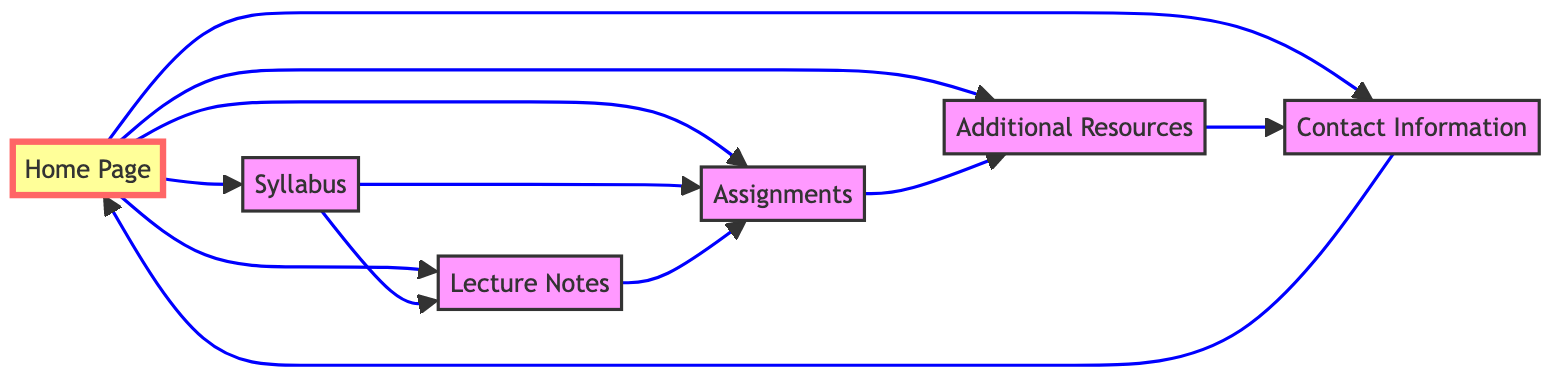What is the total number of HTML pages represented in the diagram? The diagram lists six HTML pages: Home Page, Syllabus, Lecture Notes, Assignments, Additional Resources, and Contact Information. Therefore, by counting each unique page mentioned, we find the total is six.
Answer: 6 Which page is directly linked to the Home Page? The Home Page is connected to five other pages: Syllabus, Lecture Notes, Assignments, Additional Resources, and Contact Information. To determine the direct links, we look at the edges emanating from the Home node, confirming these connections.
Answer: Syllabus, Lecture Notes, Assignments, Additional Resources, Contact Information How many hyperlinks are present in total within the diagram? The diagram contains eleven directed edges representing the hyperlinks between various pages. By counting each pair in the hyperlinks list, we find there are a total of eleven connections.
Answer: 11 From which page can you access the Additional Resources page? The Additional Resources page can be accessed directly from the Assignments page. This connection is found by examining the edges leading to the Additional Resources node and confirming that there is a direct link from Assignments.
Answer: Assignments What is the relationship between the Contact Information and Home Page? The Contact Information page links back to the Home Page. This relationship can be identified by tracing the edge that flows from the Contact node to the Home node in the diagram, indicating a directed connection.
Answer: Links back Which page has the most outgoing hyperlinks? The Home Page has five outgoing hyperlinks, connecting it to the Syllabus, Lecture Notes, Assignments, Additional Resources, and Contact Information pages. By examining the edges connected to each node, we see that the Home Page has more outgoing connections than any other page.
Answer: Home Page If a user is on the Lecture Notes page, which page can they navigate to with only one click? From the Lecture Notes page, a user can immediately navigate to the Assignments page. This is determined by checking the edges that originate from the Lecture Notes node, revealing a direct hyperlink to Assignments.
Answer: Assignments What is the starting and ending point of the hyperlink chain that involves the Contact Information page? The hyperlink chain that involves the Contact Information page starts at the Contact Information page, which links to the Home Page. This is found by checking the edge leading from Contact to Home, thereby identifying the start and end of the chain.
Answer: Contact Information to Home Page 